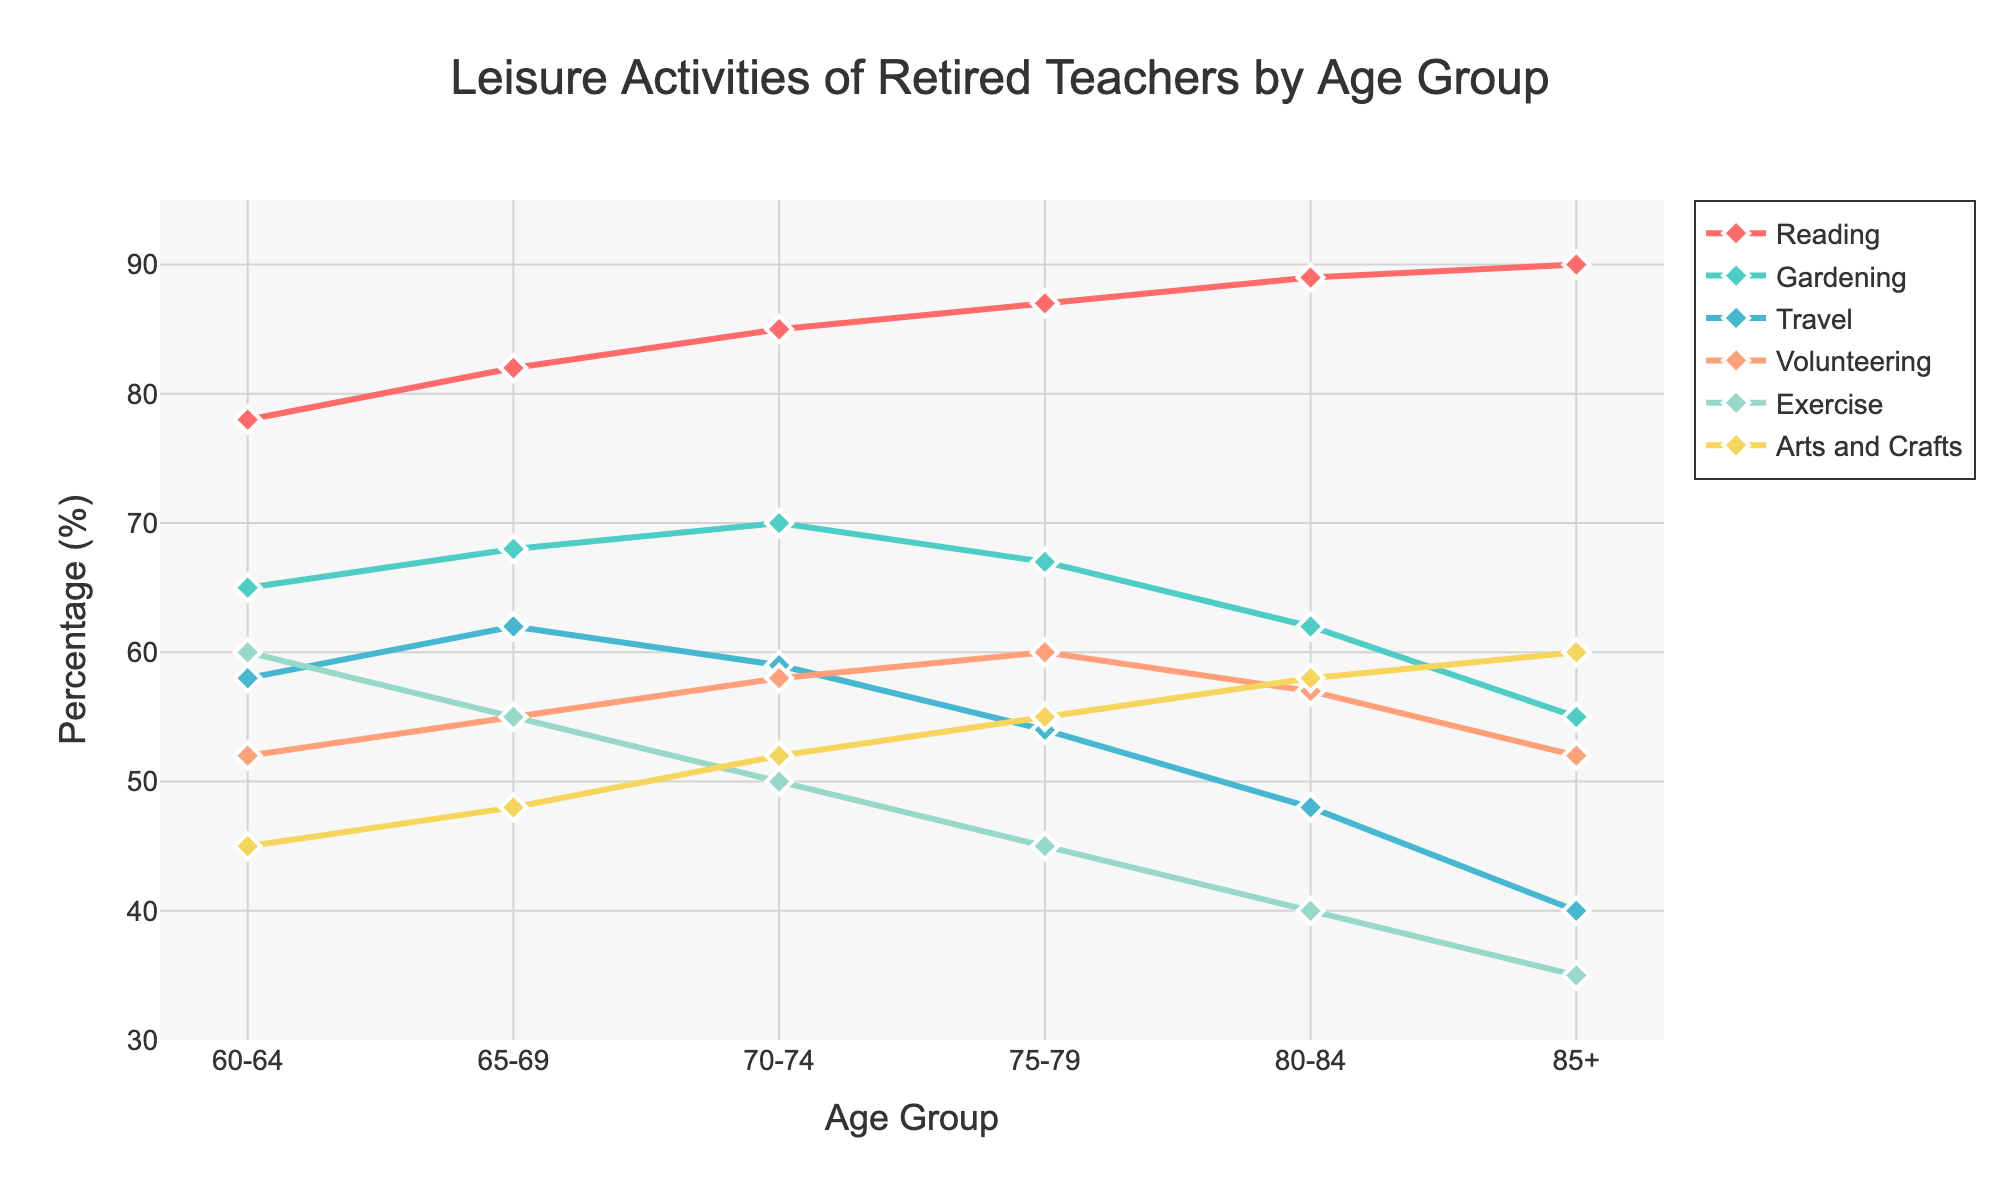Which age group has the highest percentage of retired teachers engaging in reading? Looking at the line representing reading, the highest point corresponds to the 85+ age group.
Answer: 85+ In which age group does gardening see the largest drop in percentage? By examining the gardening line, the largest drop occurs between ages 80-84 and 85+.
Answer: 85+ Compare the percentage of teachers engaging in exercise between the 60-64 and 85+ age groups. Which is higher and by how much? The percentage for exercise is 60% for ages 60-64 and 35% for ages 85+. The difference is 60% - 35% = 25%.
Answer: 60-64 by 25% What is the average percentage of teachers engaging in arts and crafts across all age groups? Summing the percentages for arts and crafts (45, 48, 52, 55, 58, 60) and dividing by the number of age groups (6): (45 + 48 + 52 + 55 + 58 + 60) / 6 = 53%.
Answer: 53% How does the percentage of teachers volunteering change from the 70-74 age group to the 75-79 age group? The percentage of volunteering increases from 58% to 60%. The change is 60% - 58% = 2%.
Answer: Increases by 2% Which activity exhibits the smallest variation in percentage from 60-64 to 85+ age groups? Comparing the variations for each activity, travel shows the smallest change, going from 58% to 40%, giving a variation of 18%.
Answer: Travel What is the total combined percentage of retired teachers engaging in reading and gardening for the 70-74 age group? Adding the percentages for reading and gardening at 70-74: 85% + 70% = 155%.
Answer: 155% Compare the percentage of teachers participating in travel and arts and crafts for the 75-79 age group. Which is higher and by how much? For ages 75-79, travel is 54% and arts and crafts are 55%. The difference is 55% - 54% = 1%.
Answer: Arts and crafts by 1% Which age group has the highest combined percentage for reading, travel, and exercise? Summing the percentages for reading, travel, and exercise for each age group and comparing them, the highest combined percentage occurs for the 60-64 group: 78% + 58% + 60% = 196%.
Answer: 60-64 What is the difference in percentage between the highest and lowest engaging activities for the 80-84 age group? The highest percentage for 80-84 is reading at 89% and the lowest is travel at 48%. The difference is 89% - 48% = 41%.
Answer: 41% 